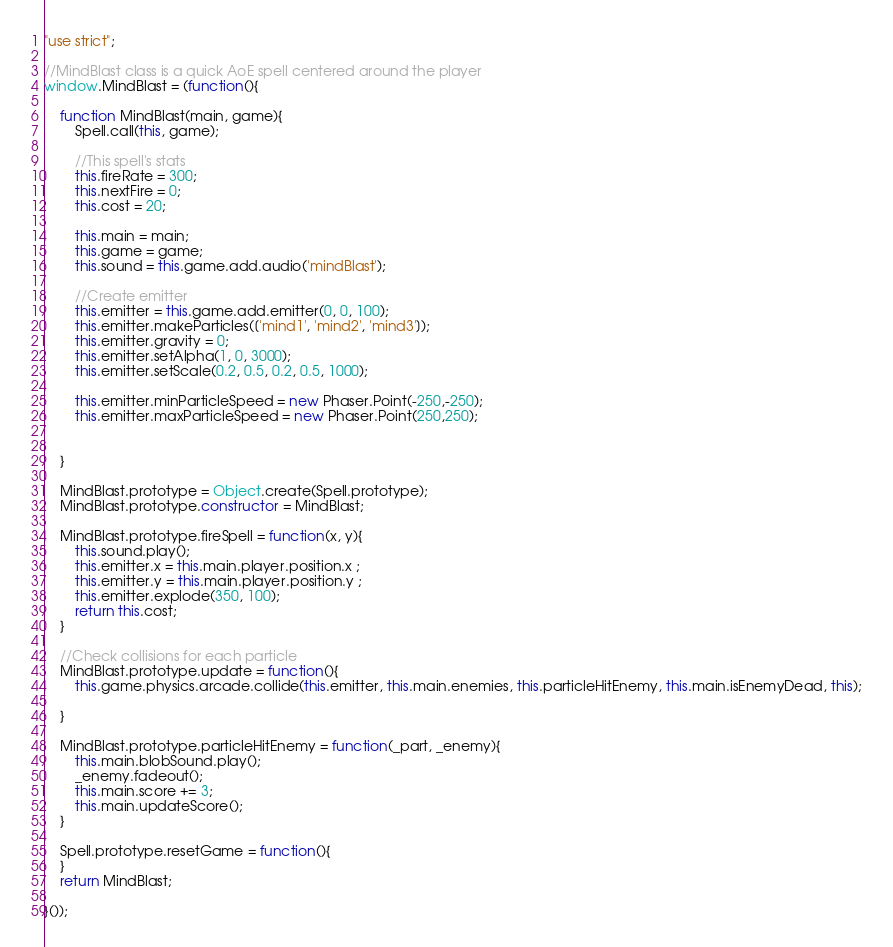<code> <loc_0><loc_0><loc_500><loc_500><_JavaScript_>"use strict";

//MindBlast class is a quick AoE spell centered around the player
window.MindBlast = (function(){

	function MindBlast(main, game){
		Spell.call(this, game);

		//This spell's stats
		this.fireRate = 300;
		this.nextFire = 0;
		this.cost = 20;

		this.main = main;
		this.game = game;
		this.sound = this.game.add.audio('mindBlast');

		//Create emitter
		this.emitter = this.game.add.emitter(0, 0, 100);
		this.emitter.makeParticles(['mind1', 'mind2', 'mind3']);
		this.emitter.gravity = 0;
		this.emitter.setAlpha(1, 0, 3000);
		this.emitter.setScale(0.2, 0.5, 0.2, 0.5, 1000);

		this.emitter.minParticleSpeed = new Phaser.Point(-250,-250);
		this.emitter.maxParticleSpeed = new Phaser.Point(250,250);

		
	}

	MindBlast.prototype = Object.create(Spell.prototype);
	MindBlast.prototype.constructor = MindBlast;

	MindBlast.prototype.fireSpell = function(x, y){
		this.sound.play();
		this.emitter.x = this.main.player.position.x ;
		this.emitter.y = this.main.player.position.y ;
		this.emitter.explode(350, 100);
		return this.cost;
	}

	//Check collisions for each particle
	MindBlast.prototype.update = function(){
		this.game.physics.arcade.collide(this.emitter, this.main.enemies, this.particleHitEnemy, this.main.isEnemyDead, this);

	}

	MindBlast.prototype.particleHitEnemy = function(_part, _enemy){
		this.main.blobSound.play();
		_enemy.fadeout();
		this.main.score += 3;
		this.main.updateScore();
	}

	Spell.prototype.resetGame = function(){ 
	}
	return MindBlast;

}());</code> 